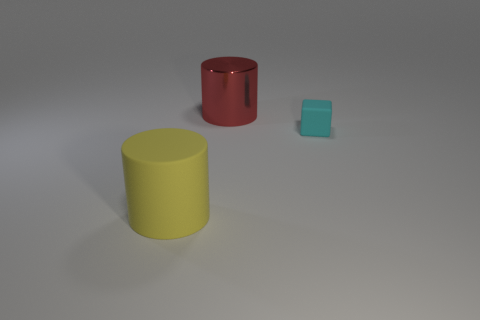Is the surface in the image reflective or matte? The surface in the image appears to be matte, as it does not reflect the objects standing on it. The shadows are softly diffused, suggesting a non-reflective, possibly textured surface. 